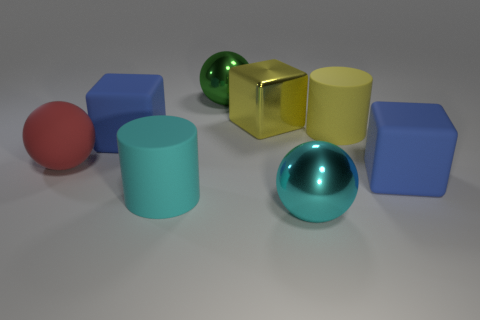How many blue matte cubes have the same size as the metallic block?
Your answer should be compact. 2. There is a cylinder that is the same color as the big metallic block; what size is it?
Offer a terse response. Large. Is the shiny block the same color as the large matte sphere?
Your answer should be compact. No. There is a large red rubber object; what shape is it?
Your answer should be compact. Sphere. Are there any tiny metal cylinders of the same color as the matte ball?
Give a very brief answer. No. Is the number of red matte things in front of the matte ball greater than the number of big gray cubes?
Offer a very short reply. No. Do the red thing and the cyan object to the left of the green shiny sphere have the same shape?
Offer a terse response. No. Is there a purple object?
Your answer should be very brief. No. What number of large things are either matte blocks or yellow metal objects?
Your answer should be compact. 3. Is the number of big cyan metal objects to the left of the big cyan metallic object greater than the number of big red rubber objects to the right of the large red object?
Provide a succinct answer. No. 